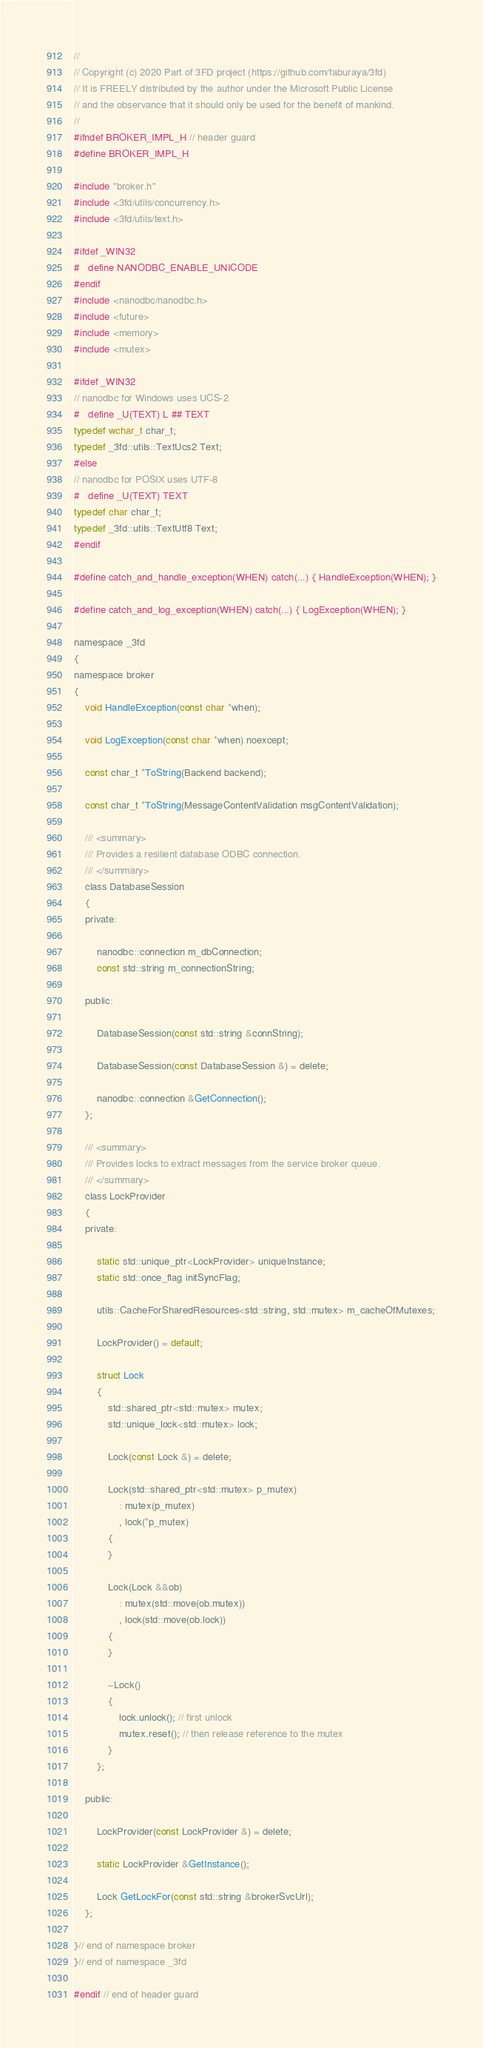Convert code to text. <code><loc_0><loc_0><loc_500><loc_500><_C_>//
// Copyright (c) 2020 Part of 3FD project (https://github.com/faburaya/3fd)
// It is FREELY distributed by the author under the Microsoft Public License
// and the observance that it should only be used for the benefit of mankind.
//
#ifndef BROKER_IMPL_H // header guard
#define BROKER_IMPL_H

#include "broker.h"
#include <3fd/utils/concurrency.h>
#include <3fd/utils/text.h>

#ifdef _WIN32
#   define NANODBC_ENABLE_UNICODE
#endif
#include <nanodbc/nanodbc.h>
#include <future>
#include <memory>
#include <mutex>

#ifdef _WIN32
// nanodbc for Windows uses UCS-2
#   define _U(TEXT) L ## TEXT
typedef wchar_t char_t;
typedef _3fd::utils::TextUcs2 Text;
#else
// nanodbc for POSIX uses UTF-8
#   define _U(TEXT) TEXT
typedef char char_t;
typedef _3fd::utils::TextUtf8 Text;
#endif

#define catch_and_handle_exception(WHEN) catch(...) { HandleException(WHEN); }

#define catch_and_log_exception(WHEN) catch(...) { LogException(WHEN); }

namespace _3fd
{
namespace broker
{
    void HandleException(const char *when);

    void LogException(const char *when) noexcept;

    const char_t *ToString(Backend backend);

    const char_t *ToString(MessageContentValidation msgContentValidation);

    /// <summary>
    /// Provides a resilient database ODBC connection.
    /// </summary>
    class DatabaseSession
    {
    private:

        nanodbc::connection m_dbConnection;
        const std::string m_connectionString;

    public:

        DatabaseSession(const std::string &connString);

        DatabaseSession(const DatabaseSession &) = delete;

        nanodbc::connection &GetConnection();
    };

    /// <summary>
    /// Provides locks to extract messages from the service broker queue.
    /// </summary>
    class LockProvider
    {
    private:

        static std::unique_ptr<LockProvider> uniqueInstance;
        static std::once_flag initSyncFlag;

        utils::CacheForSharedResources<std::string, std::mutex> m_cacheOfMutexes;

        LockProvider() = default;

        struct Lock
        {
            std::shared_ptr<std::mutex> mutex;
            std::unique_lock<std::mutex> lock;

            Lock(const Lock &) = delete;

            Lock(std::shared_ptr<std::mutex> p_mutex)
                : mutex(p_mutex)
                , lock(*p_mutex)
            {
            }

            Lock(Lock &&ob)
                : mutex(std::move(ob.mutex))
                , lock(std::move(ob.lock))
            {
            }

            ~Lock()
            {
                lock.unlock(); // first unlock
                mutex.reset(); // then release reference to the mutex
            }
        };

    public:

        LockProvider(const LockProvider &) = delete;

        static LockProvider &GetInstance();

        Lock GetLockFor(const std::string &brokerSvcUrl);
    };

}// end of namespace broker
}// end of namespace _3fd

#endif // end of header guard
</code> 